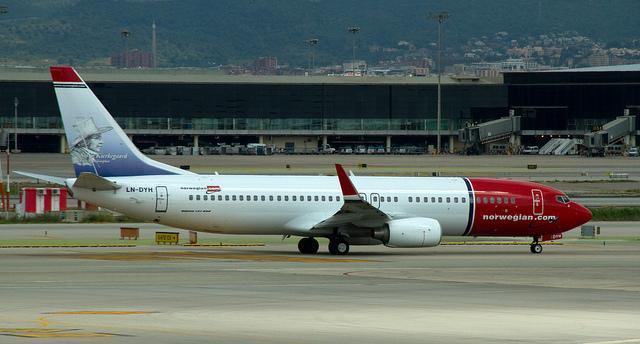How many keyboards do you see?
Give a very brief answer. 0. 